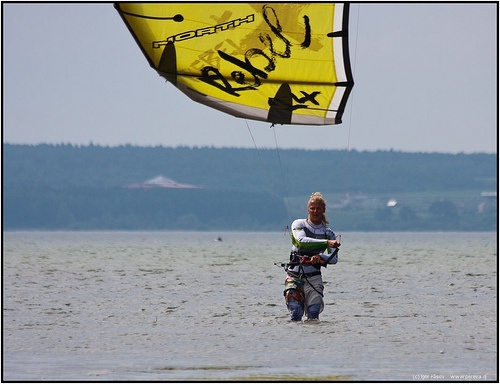Describe the objects in this image and their specific colors. I can see kite in white, gold, black, and olive tones and people in white, black, gray, and darkgray tones in this image. 